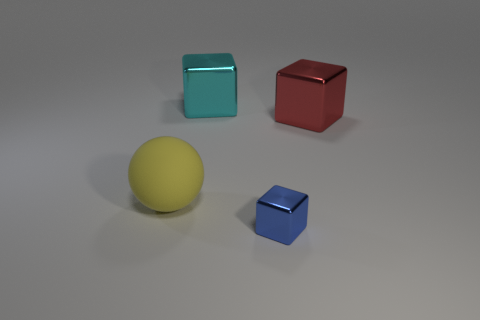How many large yellow matte spheres are behind the large matte sphere?
Offer a terse response. 0. How many cyan objects are either big shiny things or metallic blocks?
Ensure brevity in your answer.  1. The object that is behind the large shiny block that is in front of the cyan object is what color?
Offer a very short reply. Cyan. The cube in front of the big yellow matte sphere is what color?
Your response must be concise. Blue. There is a object in front of the ball; is it the same size as the large red object?
Offer a terse response. No. Are there any cyan blocks of the same size as the blue shiny object?
Provide a succinct answer. No. There is a shiny object in front of the large yellow rubber ball; does it have the same color as the big shiny cube in front of the cyan thing?
Provide a succinct answer. No. How many other things are the same shape as the large matte thing?
Your answer should be compact. 0. There is a big thing in front of the red metallic cube; what shape is it?
Provide a succinct answer. Sphere. There is a tiny blue object; is its shape the same as the large metallic thing right of the large cyan metallic cube?
Make the answer very short. Yes. 